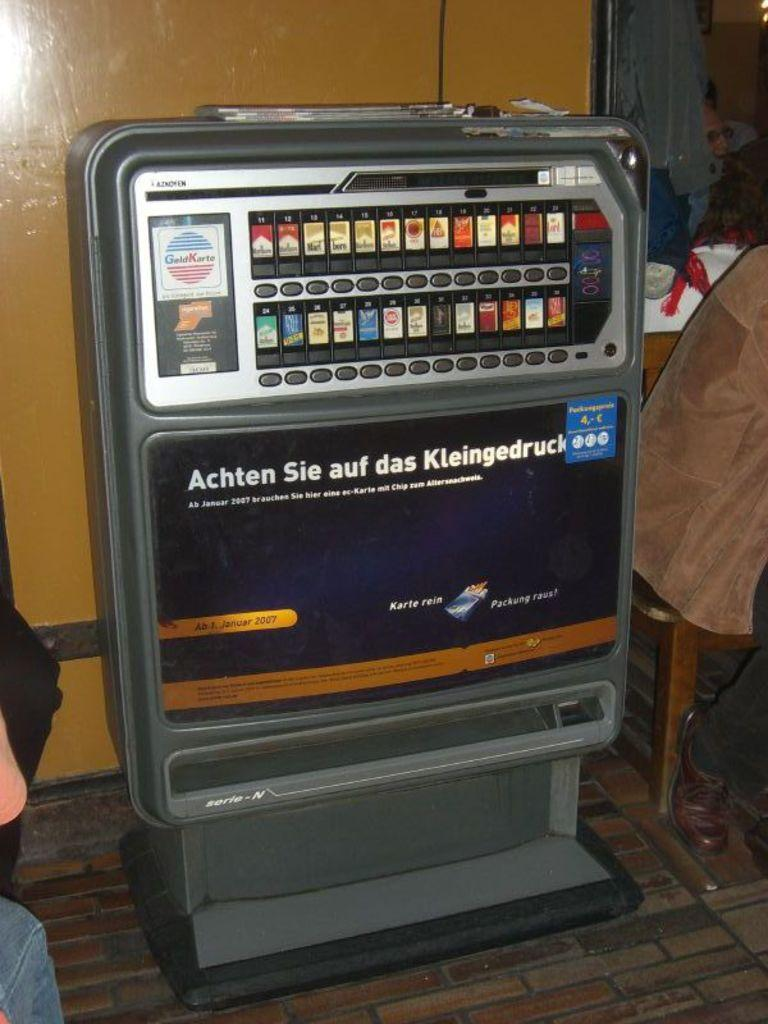What can be seen in the image that resembles a tool or machine? There is an equipment in the image. Are there any labels or instructions on the equipment? Yes, there are words written on the equipment. What type of surface is visible beneath the equipment? The floor is visible in the image. What can be seen in the background of the image? There is a wall in the background of the image. How many people are present in the image? There are two persons in the image. What type of stage is visible in the image? There is no stage present in the image. Can you identify the actor operating the equipment in the image? There is no actor present in the image, only two persons. 